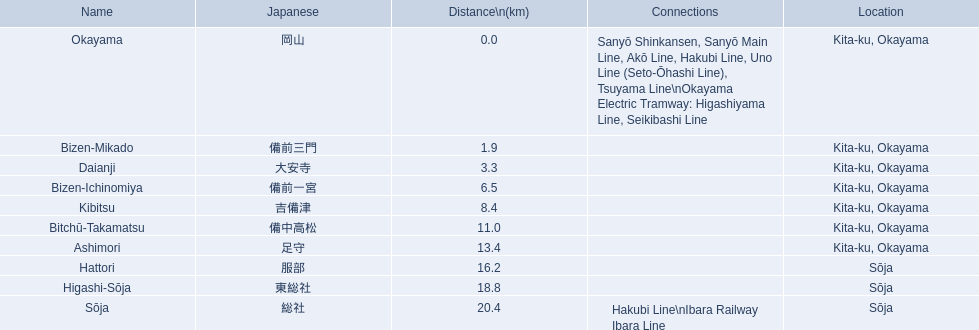What are the components of the kibi line? Okayama, Bizen-Mikado, Daianji, Bizen-Ichinomiya, Kibitsu, Bitchū-Takamatsu, Ashimori, Hattori, Higashi-Sōja, Sōja. Which ones have a distance exceeding 1 km? Bizen-Mikado, Daianji, Bizen-Ichinomiya, Kibitsu, Bitchū-Takamatsu, Ashimori, Hattori, Higashi-Sōja, Sōja. Which ones have a distance under 2 km? Okayama, Bizen-Mikado. Which has a distance ranging from 1 km to 2 km? Bizen-Mikado. 